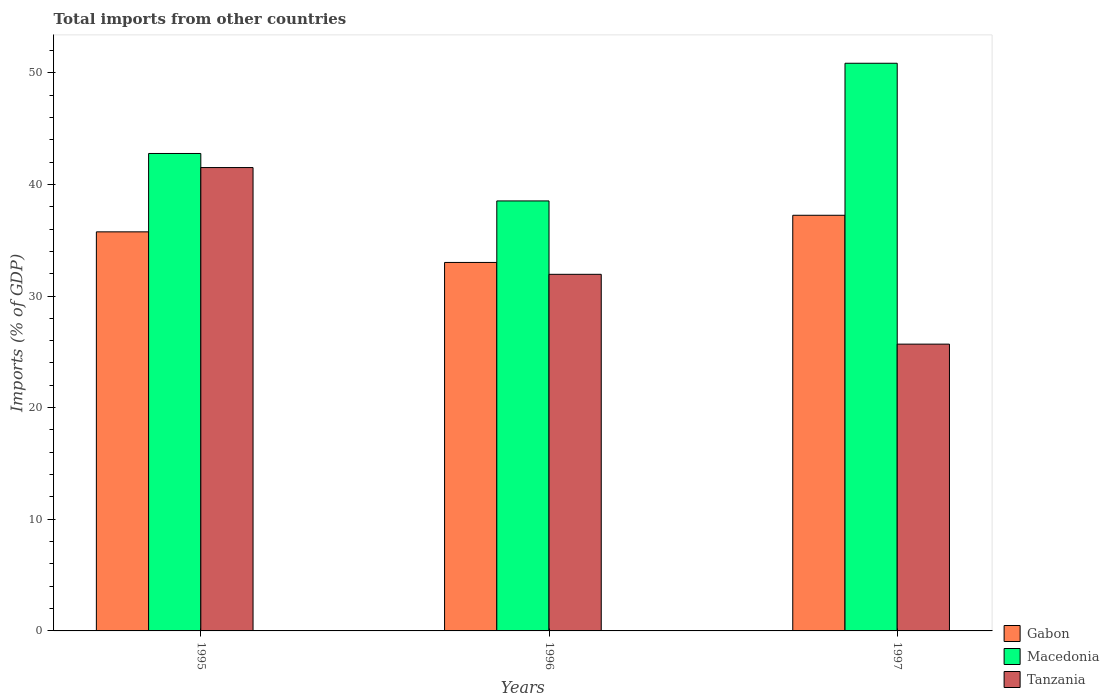Are the number of bars per tick equal to the number of legend labels?
Ensure brevity in your answer.  Yes. Are the number of bars on each tick of the X-axis equal?
Your response must be concise. Yes. How many bars are there on the 1st tick from the left?
Your answer should be very brief. 3. In how many cases, is the number of bars for a given year not equal to the number of legend labels?
Your answer should be very brief. 0. What is the total imports in Gabon in 1995?
Ensure brevity in your answer.  35.75. Across all years, what is the maximum total imports in Macedonia?
Offer a terse response. 50.85. Across all years, what is the minimum total imports in Macedonia?
Make the answer very short. 38.52. In which year was the total imports in Tanzania minimum?
Your answer should be very brief. 1997. What is the total total imports in Tanzania in the graph?
Ensure brevity in your answer.  99.14. What is the difference between the total imports in Gabon in 1996 and that in 1997?
Keep it short and to the point. -4.22. What is the difference between the total imports in Gabon in 1996 and the total imports in Tanzania in 1995?
Keep it short and to the point. -8.5. What is the average total imports in Gabon per year?
Keep it short and to the point. 35.33. In the year 1995, what is the difference between the total imports in Macedonia and total imports in Gabon?
Make the answer very short. 7.02. What is the ratio of the total imports in Tanzania in 1995 to that in 1996?
Provide a succinct answer. 1.3. Is the total imports in Tanzania in 1996 less than that in 1997?
Make the answer very short. No. What is the difference between the highest and the second highest total imports in Macedonia?
Your response must be concise. 8.08. What is the difference between the highest and the lowest total imports in Macedonia?
Give a very brief answer. 12.33. What does the 2nd bar from the left in 1997 represents?
Keep it short and to the point. Macedonia. What does the 3rd bar from the right in 1995 represents?
Give a very brief answer. Gabon. How many bars are there?
Ensure brevity in your answer.  9. Are all the bars in the graph horizontal?
Offer a very short reply. No. Are the values on the major ticks of Y-axis written in scientific E-notation?
Your answer should be compact. No. Does the graph contain grids?
Keep it short and to the point. No. What is the title of the graph?
Give a very brief answer. Total imports from other countries. What is the label or title of the Y-axis?
Give a very brief answer. Imports (% of GDP). What is the Imports (% of GDP) in Gabon in 1995?
Provide a short and direct response. 35.75. What is the Imports (% of GDP) of Macedonia in 1995?
Ensure brevity in your answer.  42.77. What is the Imports (% of GDP) in Tanzania in 1995?
Make the answer very short. 41.51. What is the Imports (% of GDP) in Gabon in 1996?
Your answer should be compact. 33.01. What is the Imports (% of GDP) in Macedonia in 1996?
Keep it short and to the point. 38.52. What is the Imports (% of GDP) in Tanzania in 1996?
Provide a succinct answer. 31.94. What is the Imports (% of GDP) of Gabon in 1997?
Make the answer very short. 37.23. What is the Imports (% of GDP) of Macedonia in 1997?
Offer a terse response. 50.85. What is the Imports (% of GDP) of Tanzania in 1997?
Offer a terse response. 25.69. Across all years, what is the maximum Imports (% of GDP) in Gabon?
Offer a very short reply. 37.23. Across all years, what is the maximum Imports (% of GDP) in Macedonia?
Provide a short and direct response. 50.85. Across all years, what is the maximum Imports (% of GDP) in Tanzania?
Your response must be concise. 41.51. Across all years, what is the minimum Imports (% of GDP) in Gabon?
Offer a terse response. 33.01. Across all years, what is the minimum Imports (% of GDP) in Macedonia?
Your answer should be very brief. 38.52. Across all years, what is the minimum Imports (% of GDP) in Tanzania?
Make the answer very short. 25.69. What is the total Imports (% of GDP) in Gabon in the graph?
Offer a very short reply. 105.99. What is the total Imports (% of GDP) in Macedonia in the graph?
Offer a terse response. 132.13. What is the total Imports (% of GDP) of Tanzania in the graph?
Ensure brevity in your answer.  99.14. What is the difference between the Imports (% of GDP) in Gabon in 1995 and that in 1996?
Give a very brief answer. 2.74. What is the difference between the Imports (% of GDP) in Macedonia in 1995 and that in 1996?
Ensure brevity in your answer.  4.25. What is the difference between the Imports (% of GDP) in Tanzania in 1995 and that in 1996?
Keep it short and to the point. 9.56. What is the difference between the Imports (% of GDP) of Gabon in 1995 and that in 1997?
Make the answer very short. -1.48. What is the difference between the Imports (% of GDP) in Macedonia in 1995 and that in 1997?
Give a very brief answer. -8.08. What is the difference between the Imports (% of GDP) in Tanzania in 1995 and that in 1997?
Offer a very short reply. 15.82. What is the difference between the Imports (% of GDP) in Gabon in 1996 and that in 1997?
Your answer should be very brief. -4.22. What is the difference between the Imports (% of GDP) of Macedonia in 1996 and that in 1997?
Offer a terse response. -12.33. What is the difference between the Imports (% of GDP) of Tanzania in 1996 and that in 1997?
Your answer should be very brief. 6.25. What is the difference between the Imports (% of GDP) in Gabon in 1995 and the Imports (% of GDP) in Macedonia in 1996?
Offer a terse response. -2.77. What is the difference between the Imports (% of GDP) of Gabon in 1995 and the Imports (% of GDP) of Tanzania in 1996?
Provide a short and direct response. 3.8. What is the difference between the Imports (% of GDP) in Macedonia in 1995 and the Imports (% of GDP) in Tanzania in 1996?
Your answer should be very brief. 10.82. What is the difference between the Imports (% of GDP) in Gabon in 1995 and the Imports (% of GDP) in Macedonia in 1997?
Give a very brief answer. -15.1. What is the difference between the Imports (% of GDP) in Gabon in 1995 and the Imports (% of GDP) in Tanzania in 1997?
Your answer should be very brief. 10.06. What is the difference between the Imports (% of GDP) of Macedonia in 1995 and the Imports (% of GDP) of Tanzania in 1997?
Keep it short and to the point. 17.08. What is the difference between the Imports (% of GDP) in Gabon in 1996 and the Imports (% of GDP) in Macedonia in 1997?
Provide a short and direct response. -17.84. What is the difference between the Imports (% of GDP) of Gabon in 1996 and the Imports (% of GDP) of Tanzania in 1997?
Make the answer very short. 7.32. What is the difference between the Imports (% of GDP) of Macedonia in 1996 and the Imports (% of GDP) of Tanzania in 1997?
Ensure brevity in your answer.  12.83. What is the average Imports (% of GDP) of Gabon per year?
Your answer should be compact. 35.33. What is the average Imports (% of GDP) of Macedonia per year?
Your response must be concise. 44.05. What is the average Imports (% of GDP) of Tanzania per year?
Offer a terse response. 33.05. In the year 1995, what is the difference between the Imports (% of GDP) of Gabon and Imports (% of GDP) of Macedonia?
Offer a very short reply. -7.02. In the year 1995, what is the difference between the Imports (% of GDP) in Gabon and Imports (% of GDP) in Tanzania?
Ensure brevity in your answer.  -5.76. In the year 1995, what is the difference between the Imports (% of GDP) in Macedonia and Imports (% of GDP) in Tanzania?
Your answer should be compact. 1.26. In the year 1996, what is the difference between the Imports (% of GDP) of Gabon and Imports (% of GDP) of Macedonia?
Give a very brief answer. -5.51. In the year 1996, what is the difference between the Imports (% of GDP) in Gabon and Imports (% of GDP) in Tanzania?
Give a very brief answer. 1.06. In the year 1996, what is the difference between the Imports (% of GDP) in Macedonia and Imports (% of GDP) in Tanzania?
Your answer should be very brief. 6.57. In the year 1997, what is the difference between the Imports (% of GDP) in Gabon and Imports (% of GDP) in Macedonia?
Ensure brevity in your answer.  -13.62. In the year 1997, what is the difference between the Imports (% of GDP) in Gabon and Imports (% of GDP) in Tanzania?
Give a very brief answer. 11.54. In the year 1997, what is the difference between the Imports (% of GDP) of Macedonia and Imports (% of GDP) of Tanzania?
Keep it short and to the point. 25.16. What is the ratio of the Imports (% of GDP) in Gabon in 1995 to that in 1996?
Ensure brevity in your answer.  1.08. What is the ratio of the Imports (% of GDP) in Macedonia in 1995 to that in 1996?
Keep it short and to the point. 1.11. What is the ratio of the Imports (% of GDP) in Tanzania in 1995 to that in 1996?
Ensure brevity in your answer.  1.3. What is the ratio of the Imports (% of GDP) in Gabon in 1995 to that in 1997?
Offer a very short reply. 0.96. What is the ratio of the Imports (% of GDP) in Macedonia in 1995 to that in 1997?
Make the answer very short. 0.84. What is the ratio of the Imports (% of GDP) in Tanzania in 1995 to that in 1997?
Give a very brief answer. 1.62. What is the ratio of the Imports (% of GDP) of Gabon in 1996 to that in 1997?
Ensure brevity in your answer.  0.89. What is the ratio of the Imports (% of GDP) of Macedonia in 1996 to that in 1997?
Offer a very short reply. 0.76. What is the ratio of the Imports (% of GDP) in Tanzania in 1996 to that in 1997?
Make the answer very short. 1.24. What is the difference between the highest and the second highest Imports (% of GDP) in Gabon?
Provide a succinct answer. 1.48. What is the difference between the highest and the second highest Imports (% of GDP) of Macedonia?
Ensure brevity in your answer.  8.08. What is the difference between the highest and the second highest Imports (% of GDP) of Tanzania?
Your answer should be very brief. 9.56. What is the difference between the highest and the lowest Imports (% of GDP) in Gabon?
Offer a terse response. 4.22. What is the difference between the highest and the lowest Imports (% of GDP) of Macedonia?
Your answer should be very brief. 12.33. What is the difference between the highest and the lowest Imports (% of GDP) in Tanzania?
Ensure brevity in your answer.  15.82. 